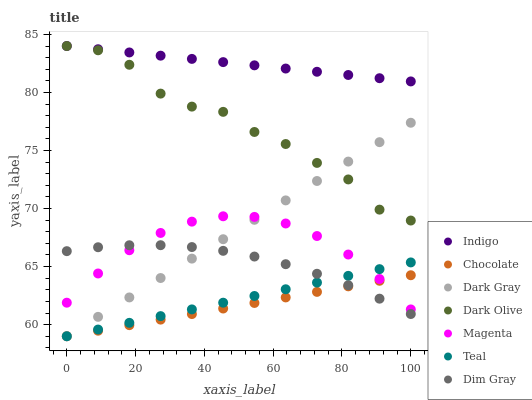Does Chocolate have the minimum area under the curve?
Answer yes or no. Yes. Does Indigo have the maximum area under the curve?
Answer yes or no. Yes. Does Dark Olive have the minimum area under the curve?
Answer yes or no. No. Does Dark Olive have the maximum area under the curve?
Answer yes or no. No. Is Chocolate the smoothest?
Answer yes or no. Yes. Is Dark Olive the roughest?
Answer yes or no. Yes. Is Indigo the smoothest?
Answer yes or no. No. Is Indigo the roughest?
Answer yes or no. No. Does Chocolate have the lowest value?
Answer yes or no. Yes. Does Dark Olive have the lowest value?
Answer yes or no. No. Does Dark Olive have the highest value?
Answer yes or no. Yes. Does Chocolate have the highest value?
Answer yes or no. No. Is Teal less than Dark Olive?
Answer yes or no. Yes. Is Indigo greater than Teal?
Answer yes or no. Yes. Does Teal intersect Dark Gray?
Answer yes or no. Yes. Is Teal less than Dark Gray?
Answer yes or no. No. Is Teal greater than Dark Gray?
Answer yes or no. No. Does Teal intersect Dark Olive?
Answer yes or no. No. 